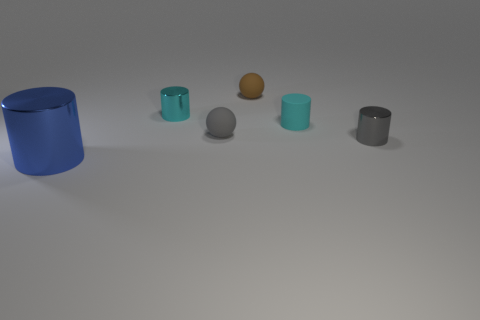Add 3 gray rubber things. How many objects exist? 9 Subtract all cylinders. How many objects are left? 2 Add 4 small gray cylinders. How many small gray cylinders are left? 5 Add 2 cyan matte objects. How many cyan matte objects exist? 3 Subtract 1 blue cylinders. How many objects are left? 5 Subtract all large brown blocks. Subtract all brown matte objects. How many objects are left? 5 